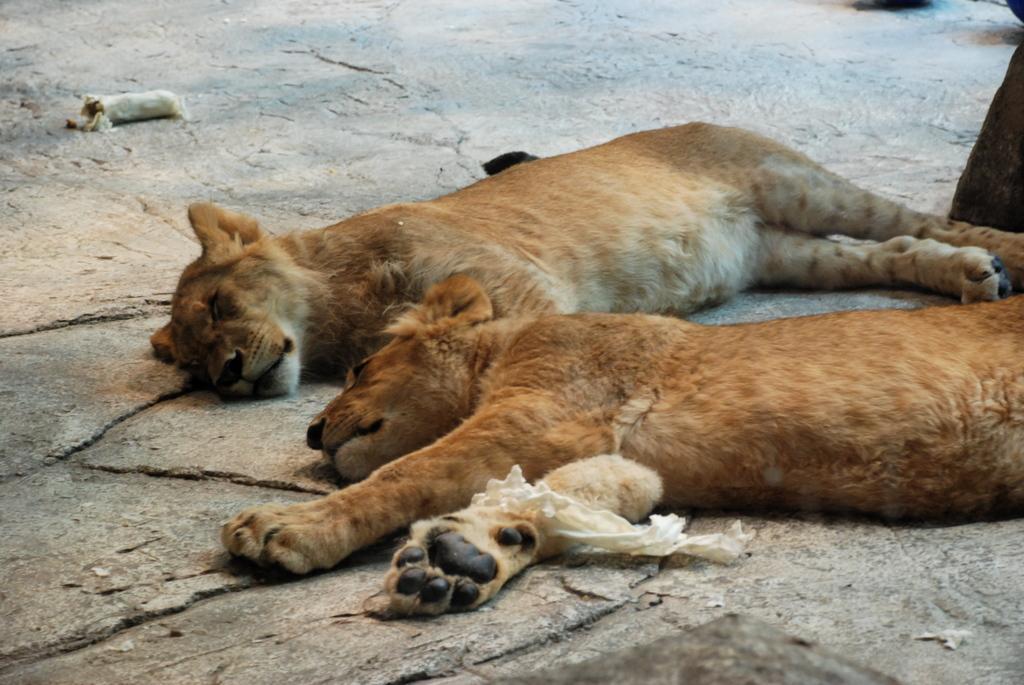Describe this image in one or two sentences. In this image we can see tigers sleeping on the floor. 